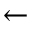<formula> <loc_0><loc_0><loc_500><loc_500>\leftarrow</formula> 